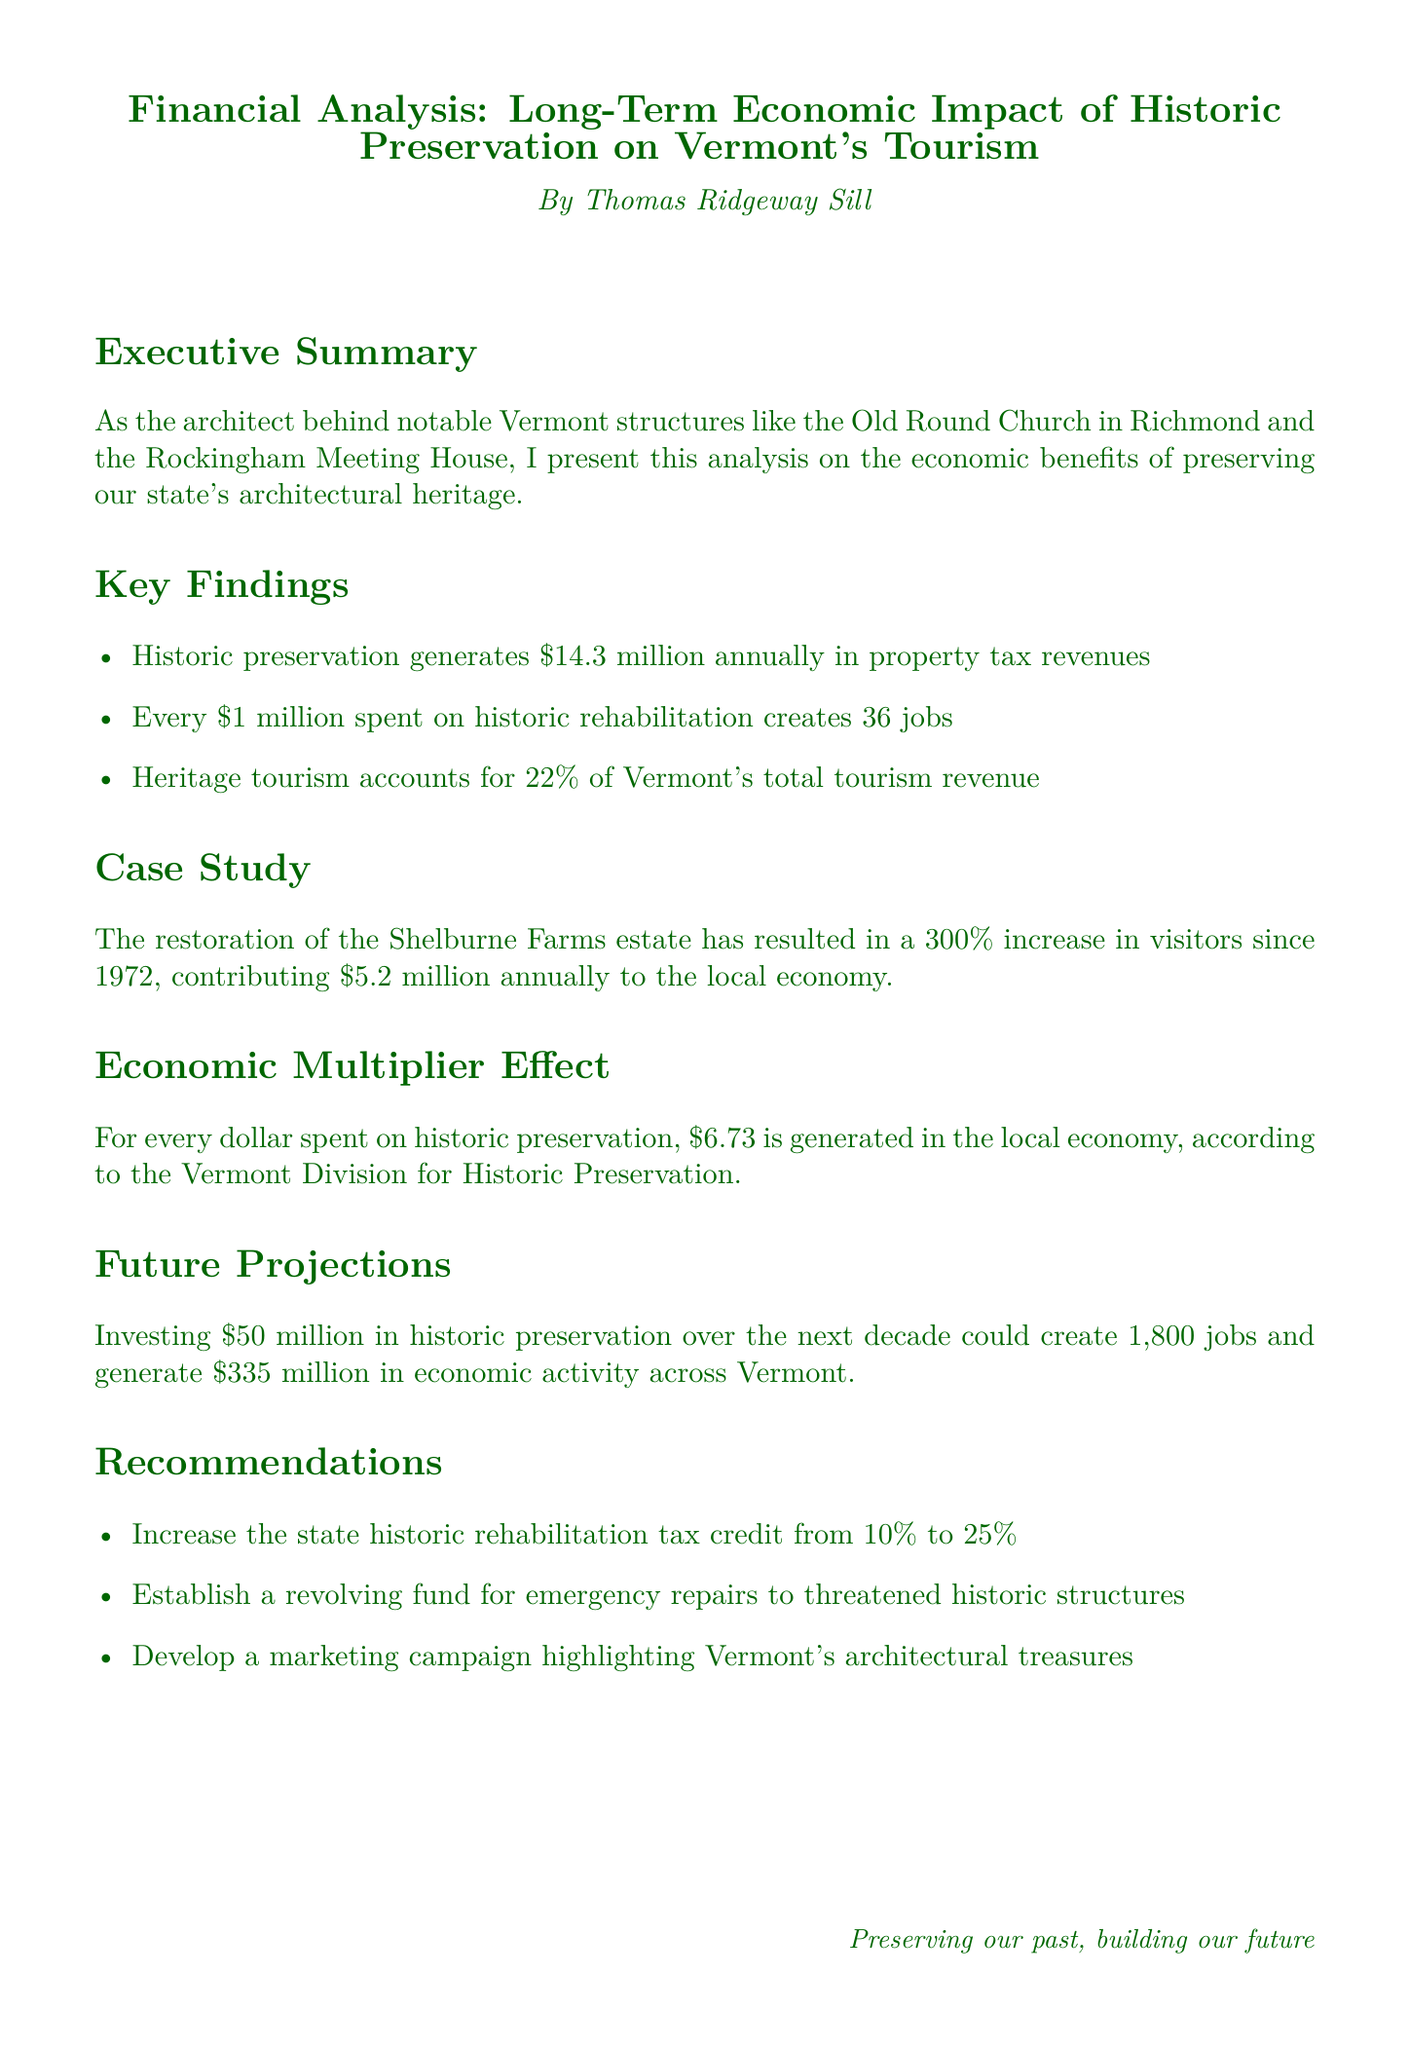What is the annual property tax revenue generated from historic preservation? The document states that historic preservation generates $14.3 million annually in property tax revenues.
Answer: $14.3 million How many jobs are created for every $1 million spent on historic rehabilitation? According to the document, every $1 million spent on historic rehabilitation creates 36 jobs.
Answer: 36 jobs What percentage of Vermont's total tourism revenue is accounted for by heritage tourism? The document mentions that heritage tourism accounts for 22% of Vermont's total tourism revenue.
Answer: 22% What is the increase in visitors to Shelburne Farms since 1972? The restoration of the Shelburne Farms estate has resulted in a 300% increase in visitors since 1972.
Answer: 300% What is the economic multiplier effect of spending on historic preservation? The document states that for every dollar spent on historic preservation, $6.73 is generated in the local economy.
Answer: $6.73 How much could be generated in economic activity by investing $50 million in historic preservation? Investing $50 million in historic preservation over the next decade could generate $335 million in economic activity across Vermont.
Answer: $335 million What is the proposed increase for the state historic rehabilitation tax credit? The recommendations include increasing the state historic rehabilitation tax credit from 10% to 25%.
Answer: 25% What type of fund is recommended for emergency repairs to threatened historic structures? The document suggests establishing a revolving fund for emergency repairs to threatened historic structures.
Answer: Revolving fund What is the name of the author of the financial analysis? The document lists Thomas Ridgeway Sill as the author of the analysis.
Answer: Thomas Ridgeway Sill 